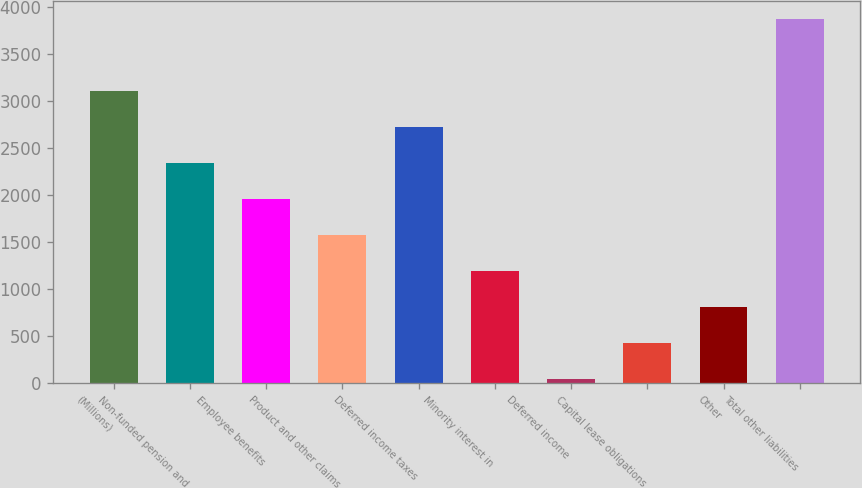Convert chart. <chart><loc_0><loc_0><loc_500><loc_500><bar_chart><fcel>(Millions)<fcel>Non-funded pension and<fcel>Employee benefits<fcel>Product and other claims<fcel>Deferred income taxes<fcel>Minority interest in<fcel>Deferred income<fcel>Capital lease obligations<fcel>Other<fcel>Total other liabilities<nl><fcel>3101.8<fcel>2337.6<fcel>1955.5<fcel>1573.4<fcel>2719.7<fcel>1191.3<fcel>45<fcel>427.1<fcel>809.2<fcel>3866<nl></chart> 